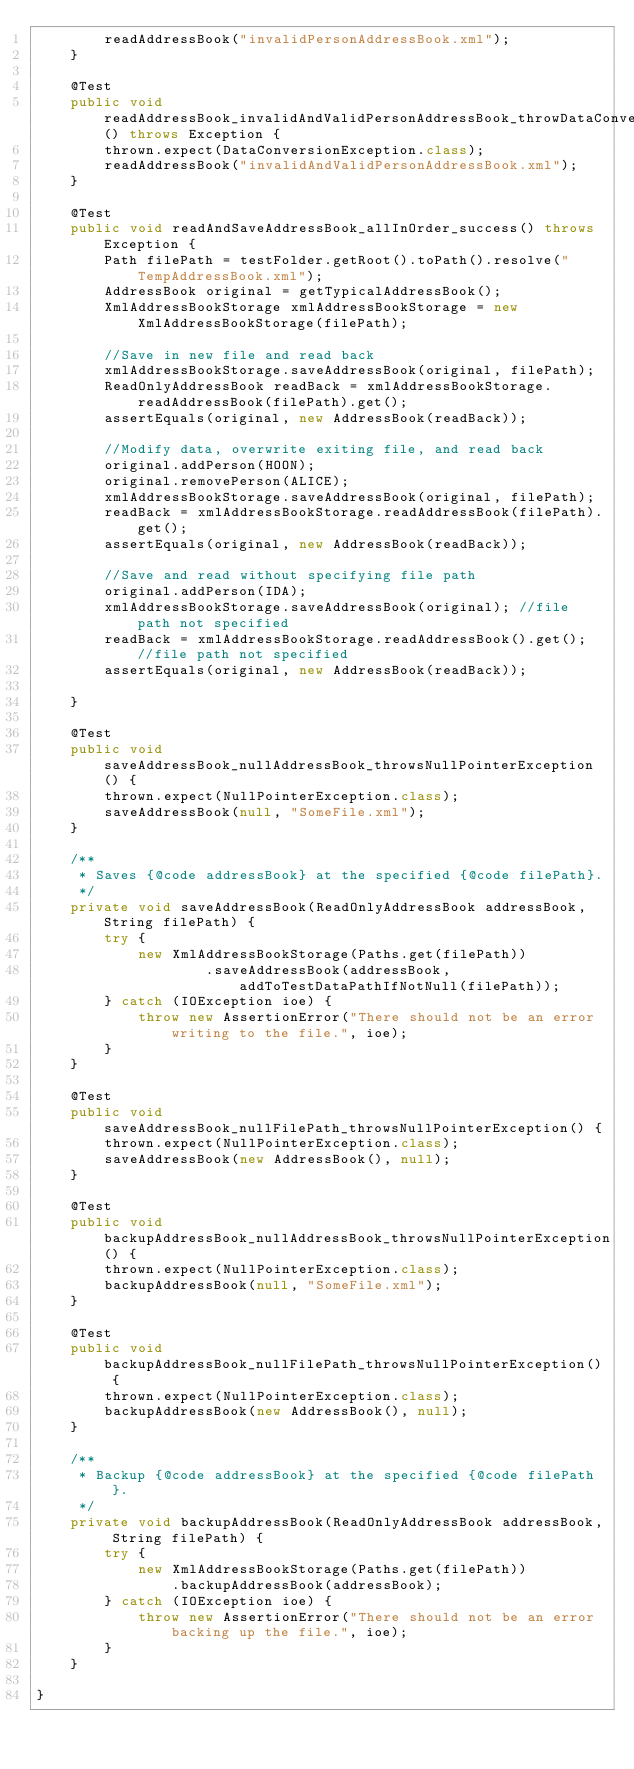Convert code to text. <code><loc_0><loc_0><loc_500><loc_500><_Java_>        readAddressBook("invalidPersonAddressBook.xml");
    }

    @Test
    public void readAddressBook_invalidAndValidPersonAddressBook_throwDataConversionException() throws Exception {
        thrown.expect(DataConversionException.class);
        readAddressBook("invalidAndValidPersonAddressBook.xml");
    }

    @Test
    public void readAndSaveAddressBook_allInOrder_success() throws Exception {
        Path filePath = testFolder.getRoot().toPath().resolve("TempAddressBook.xml");
        AddressBook original = getTypicalAddressBook();
        XmlAddressBookStorage xmlAddressBookStorage = new XmlAddressBookStorage(filePath);

        //Save in new file and read back
        xmlAddressBookStorage.saveAddressBook(original, filePath);
        ReadOnlyAddressBook readBack = xmlAddressBookStorage.readAddressBook(filePath).get();
        assertEquals(original, new AddressBook(readBack));

        //Modify data, overwrite exiting file, and read back
        original.addPerson(HOON);
        original.removePerson(ALICE);
        xmlAddressBookStorage.saveAddressBook(original, filePath);
        readBack = xmlAddressBookStorage.readAddressBook(filePath).get();
        assertEquals(original, new AddressBook(readBack));

        //Save and read without specifying file path
        original.addPerson(IDA);
        xmlAddressBookStorage.saveAddressBook(original); //file path not specified
        readBack = xmlAddressBookStorage.readAddressBook().get(); //file path not specified
        assertEquals(original, new AddressBook(readBack));

    }

    @Test
    public void saveAddressBook_nullAddressBook_throwsNullPointerException() {
        thrown.expect(NullPointerException.class);
        saveAddressBook(null, "SomeFile.xml");
    }

    /**
     * Saves {@code addressBook} at the specified {@code filePath}.
     */
    private void saveAddressBook(ReadOnlyAddressBook addressBook, String filePath) {
        try {
            new XmlAddressBookStorage(Paths.get(filePath))
                    .saveAddressBook(addressBook, addToTestDataPathIfNotNull(filePath));
        } catch (IOException ioe) {
            throw new AssertionError("There should not be an error writing to the file.", ioe);
        }
    }

    @Test
    public void saveAddressBook_nullFilePath_throwsNullPointerException() {
        thrown.expect(NullPointerException.class);
        saveAddressBook(new AddressBook(), null);
    }

    @Test
    public void backupAddressBook_nullAddressBook_throwsNullPointerException() {
        thrown.expect(NullPointerException.class);
        backupAddressBook(null, "SomeFile.xml");
    }

    @Test
    public void backupAddressBook_nullFilePath_throwsNullPointerException() {
        thrown.expect(NullPointerException.class);
        backupAddressBook(new AddressBook(), null);
    }

    /**
     * Backup {@code addressBook} at the specified {@code filePath}.
     */
    private void backupAddressBook(ReadOnlyAddressBook addressBook, String filePath) {
        try {
            new XmlAddressBookStorage(Paths.get(filePath))
                .backupAddressBook(addressBook);
        } catch (IOException ioe) {
            throw new AssertionError("There should not be an error backing up the file.", ioe);
        }
    }

}
</code> 